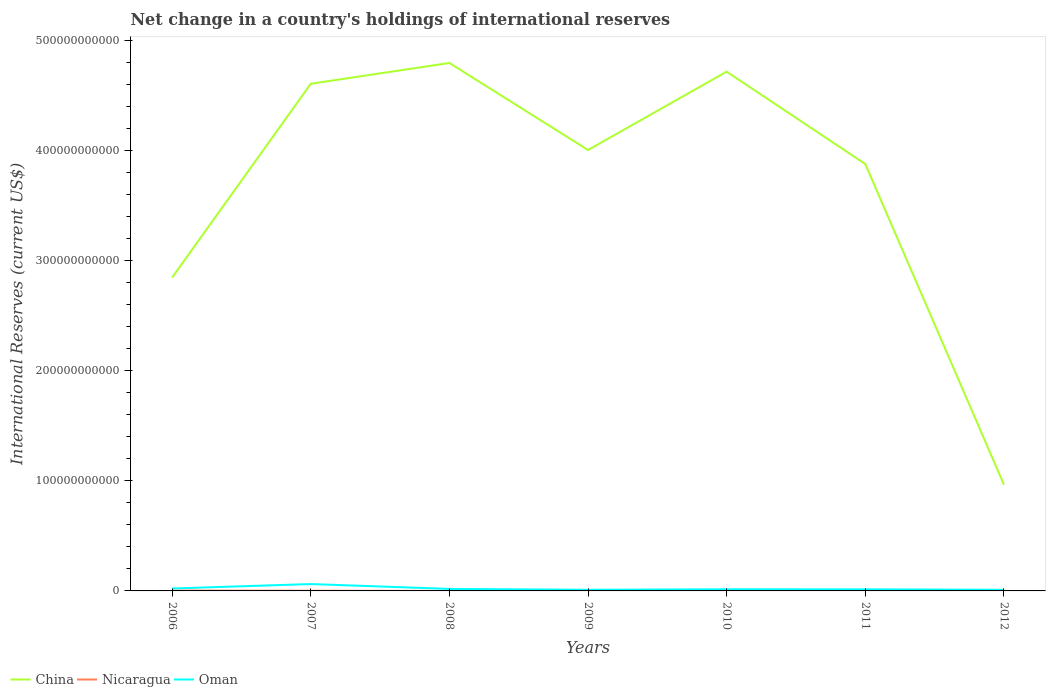Does the line corresponding to China intersect with the line corresponding to Oman?
Your answer should be very brief. No. Is the number of lines equal to the number of legend labels?
Provide a short and direct response. No. Across all years, what is the maximum international reserves in China?
Give a very brief answer. 9.66e+1. What is the total international reserves in Oman in the graph?
Provide a short and direct response. -4.11e+08. What is the difference between the highest and the second highest international reserves in Oman?
Provide a succinct answer. 5.22e+09. What is the difference between the highest and the lowest international reserves in Oman?
Your response must be concise. 2. What is the difference between two consecutive major ticks on the Y-axis?
Your answer should be compact. 1.00e+11. Are the values on the major ticks of Y-axis written in scientific E-notation?
Offer a terse response. No. Does the graph contain any zero values?
Provide a succinct answer. Yes. Does the graph contain grids?
Make the answer very short. No. How many legend labels are there?
Provide a succinct answer. 3. What is the title of the graph?
Provide a short and direct response. Net change in a country's holdings of international reserves. Does "Jordan" appear as one of the legend labels in the graph?
Give a very brief answer. No. What is the label or title of the Y-axis?
Provide a succinct answer. International Reserves (current US$). What is the International Reserves (current US$) in China in 2006?
Give a very brief answer. 2.85e+11. What is the International Reserves (current US$) in Nicaragua in 2006?
Offer a terse response. 3.20e+08. What is the International Reserves (current US$) in Oman in 2006?
Provide a short and direct response. 2.21e+09. What is the International Reserves (current US$) of China in 2007?
Provide a succinct answer. 4.61e+11. What is the International Reserves (current US$) of Nicaragua in 2007?
Your answer should be compact. 1.49e+08. What is the International Reserves (current US$) of Oman in 2007?
Keep it short and to the point. 6.25e+09. What is the International Reserves (current US$) of China in 2008?
Your response must be concise. 4.80e+11. What is the International Reserves (current US$) in Nicaragua in 2008?
Offer a very short reply. 2.91e+06. What is the International Reserves (current US$) of Oman in 2008?
Offer a terse response. 1.83e+09. What is the International Reserves (current US$) of China in 2009?
Ensure brevity in your answer.  4.01e+11. What is the International Reserves (current US$) in Nicaragua in 2009?
Ensure brevity in your answer.  3.85e+08. What is the International Reserves (current US$) in Oman in 2009?
Provide a short and direct response. 1.05e+09. What is the International Reserves (current US$) in China in 2010?
Provide a short and direct response. 4.72e+11. What is the International Reserves (current US$) of Nicaragua in 2010?
Make the answer very short. 2.02e+08. What is the International Reserves (current US$) in Oman in 2010?
Make the answer very short. 1.50e+09. What is the International Reserves (current US$) in China in 2011?
Provide a succinct answer. 3.88e+11. What is the International Reserves (current US$) of Nicaragua in 2011?
Provide a short and direct response. 7.26e+07. What is the International Reserves (current US$) in Oman in 2011?
Ensure brevity in your answer.  1.46e+09. What is the International Reserves (current US$) of China in 2012?
Your response must be concise. 9.66e+1. What is the International Reserves (current US$) of Oman in 2012?
Give a very brief answer. 1.03e+09. Across all years, what is the maximum International Reserves (current US$) in China?
Keep it short and to the point. 4.80e+11. Across all years, what is the maximum International Reserves (current US$) of Nicaragua?
Provide a succinct answer. 3.85e+08. Across all years, what is the maximum International Reserves (current US$) in Oman?
Offer a terse response. 6.25e+09. Across all years, what is the minimum International Reserves (current US$) of China?
Offer a very short reply. 9.66e+1. Across all years, what is the minimum International Reserves (current US$) in Nicaragua?
Ensure brevity in your answer.  0. Across all years, what is the minimum International Reserves (current US$) in Oman?
Give a very brief answer. 1.03e+09. What is the total International Reserves (current US$) of China in the graph?
Your answer should be compact. 2.58e+12. What is the total International Reserves (current US$) in Nicaragua in the graph?
Offer a terse response. 1.13e+09. What is the total International Reserves (current US$) in Oman in the graph?
Offer a terse response. 1.53e+1. What is the difference between the International Reserves (current US$) of China in 2006 and that in 2007?
Make the answer very short. -1.76e+11. What is the difference between the International Reserves (current US$) in Nicaragua in 2006 and that in 2007?
Your answer should be compact. 1.72e+08. What is the difference between the International Reserves (current US$) of Oman in 2006 and that in 2007?
Keep it short and to the point. -4.04e+09. What is the difference between the International Reserves (current US$) of China in 2006 and that in 2008?
Keep it short and to the point. -1.95e+11. What is the difference between the International Reserves (current US$) of Nicaragua in 2006 and that in 2008?
Ensure brevity in your answer.  3.17e+08. What is the difference between the International Reserves (current US$) in Oman in 2006 and that in 2008?
Make the answer very short. 3.79e+08. What is the difference between the International Reserves (current US$) in China in 2006 and that in 2009?
Provide a short and direct response. -1.16e+11. What is the difference between the International Reserves (current US$) of Nicaragua in 2006 and that in 2009?
Your answer should be compact. -6.45e+07. What is the difference between the International Reserves (current US$) of Oman in 2006 and that in 2009?
Provide a succinct answer. 1.16e+09. What is the difference between the International Reserves (current US$) of China in 2006 and that in 2010?
Keep it short and to the point. -1.87e+11. What is the difference between the International Reserves (current US$) of Nicaragua in 2006 and that in 2010?
Provide a short and direct response. 1.18e+08. What is the difference between the International Reserves (current US$) in Oman in 2006 and that in 2010?
Keep it short and to the point. 7.02e+08. What is the difference between the International Reserves (current US$) of China in 2006 and that in 2011?
Offer a very short reply. -1.03e+11. What is the difference between the International Reserves (current US$) of Nicaragua in 2006 and that in 2011?
Your answer should be very brief. 2.48e+08. What is the difference between the International Reserves (current US$) of Oman in 2006 and that in 2011?
Your answer should be compact. 7.45e+08. What is the difference between the International Reserves (current US$) in China in 2006 and that in 2012?
Make the answer very short. 1.88e+11. What is the difference between the International Reserves (current US$) of Oman in 2006 and that in 2012?
Ensure brevity in your answer.  1.17e+09. What is the difference between the International Reserves (current US$) in China in 2007 and that in 2008?
Your response must be concise. -1.89e+1. What is the difference between the International Reserves (current US$) of Nicaragua in 2007 and that in 2008?
Your answer should be compact. 1.46e+08. What is the difference between the International Reserves (current US$) in Oman in 2007 and that in 2008?
Ensure brevity in your answer.  4.42e+09. What is the difference between the International Reserves (current US$) in China in 2007 and that in 2009?
Your answer should be very brief. 6.01e+1. What is the difference between the International Reserves (current US$) in Nicaragua in 2007 and that in 2009?
Ensure brevity in your answer.  -2.36e+08. What is the difference between the International Reserves (current US$) in Oman in 2007 and that in 2009?
Offer a terse response. 5.20e+09. What is the difference between the International Reserves (current US$) in China in 2007 and that in 2010?
Your answer should be very brief. -1.10e+1. What is the difference between the International Reserves (current US$) of Nicaragua in 2007 and that in 2010?
Your answer should be compact. -5.34e+07. What is the difference between the International Reserves (current US$) in Oman in 2007 and that in 2010?
Keep it short and to the point. 4.75e+09. What is the difference between the International Reserves (current US$) in China in 2007 and that in 2011?
Give a very brief answer. 7.29e+1. What is the difference between the International Reserves (current US$) in Nicaragua in 2007 and that in 2011?
Your answer should be compact. 7.60e+07. What is the difference between the International Reserves (current US$) in Oman in 2007 and that in 2011?
Give a very brief answer. 4.79e+09. What is the difference between the International Reserves (current US$) of China in 2007 and that in 2012?
Make the answer very short. 3.64e+11. What is the difference between the International Reserves (current US$) in Oman in 2007 and that in 2012?
Offer a very short reply. 5.22e+09. What is the difference between the International Reserves (current US$) in China in 2008 and that in 2009?
Give a very brief answer. 7.90e+1. What is the difference between the International Reserves (current US$) of Nicaragua in 2008 and that in 2009?
Offer a terse response. -3.82e+08. What is the difference between the International Reserves (current US$) in Oman in 2008 and that in 2009?
Offer a terse response. 7.77e+08. What is the difference between the International Reserves (current US$) in China in 2008 and that in 2010?
Provide a succinct answer. 7.89e+09. What is the difference between the International Reserves (current US$) in Nicaragua in 2008 and that in 2010?
Provide a succinct answer. -1.99e+08. What is the difference between the International Reserves (current US$) in Oman in 2008 and that in 2010?
Offer a very short reply. 3.23e+08. What is the difference between the International Reserves (current US$) of China in 2008 and that in 2011?
Provide a succinct answer. 9.18e+1. What is the difference between the International Reserves (current US$) in Nicaragua in 2008 and that in 2011?
Your answer should be compact. -6.97e+07. What is the difference between the International Reserves (current US$) of Oman in 2008 and that in 2011?
Give a very brief answer. 3.66e+08. What is the difference between the International Reserves (current US$) of China in 2008 and that in 2012?
Your answer should be compact. 3.83e+11. What is the difference between the International Reserves (current US$) in Oman in 2008 and that in 2012?
Offer a very short reply. 7.94e+08. What is the difference between the International Reserves (current US$) in China in 2009 and that in 2010?
Make the answer very short. -7.12e+1. What is the difference between the International Reserves (current US$) of Nicaragua in 2009 and that in 2010?
Offer a terse response. 1.83e+08. What is the difference between the International Reserves (current US$) of Oman in 2009 and that in 2010?
Offer a terse response. -4.54e+08. What is the difference between the International Reserves (current US$) of China in 2009 and that in 2011?
Your answer should be very brief. 1.27e+1. What is the difference between the International Reserves (current US$) of Nicaragua in 2009 and that in 2011?
Make the answer very short. 3.12e+08. What is the difference between the International Reserves (current US$) of Oman in 2009 and that in 2011?
Your answer should be compact. -4.11e+08. What is the difference between the International Reserves (current US$) of China in 2009 and that in 2012?
Make the answer very short. 3.04e+11. What is the difference between the International Reserves (current US$) of Oman in 2009 and that in 2012?
Give a very brief answer. 1.64e+07. What is the difference between the International Reserves (current US$) in China in 2010 and that in 2011?
Offer a very short reply. 8.39e+1. What is the difference between the International Reserves (current US$) of Nicaragua in 2010 and that in 2011?
Provide a succinct answer. 1.29e+08. What is the difference between the International Reserves (current US$) in Oman in 2010 and that in 2011?
Ensure brevity in your answer.  4.31e+07. What is the difference between the International Reserves (current US$) of China in 2010 and that in 2012?
Your answer should be compact. 3.75e+11. What is the difference between the International Reserves (current US$) of Oman in 2010 and that in 2012?
Your answer should be compact. 4.71e+08. What is the difference between the International Reserves (current US$) in China in 2011 and that in 2012?
Ensure brevity in your answer.  2.91e+11. What is the difference between the International Reserves (current US$) in Oman in 2011 and that in 2012?
Ensure brevity in your answer.  4.28e+08. What is the difference between the International Reserves (current US$) in China in 2006 and the International Reserves (current US$) in Nicaragua in 2007?
Your answer should be very brief. 2.85e+11. What is the difference between the International Reserves (current US$) of China in 2006 and the International Reserves (current US$) of Oman in 2007?
Your answer should be very brief. 2.78e+11. What is the difference between the International Reserves (current US$) in Nicaragua in 2006 and the International Reserves (current US$) in Oman in 2007?
Make the answer very short. -5.93e+09. What is the difference between the International Reserves (current US$) in China in 2006 and the International Reserves (current US$) in Nicaragua in 2008?
Your answer should be compact. 2.85e+11. What is the difference between the International Reserves (current US$) in China in 2006 and the International Reserves (current US$) in Oman in 2008?
Provide a succinct answer. 2.83e+11. What is the difference between the International Reserves (current US$) of Nicaragua in 2006 and the International Reserves (current US$) of Oman in 2008?
Keep it short and to the point. -1.51e+09. What is the difference between the International Reserves (current US$) of China in 2006 and the International Reserves (current US$) of Nicaragua in 2009?
Your answer should be compact. 2.84e+11. What is the difference between the International Reserves (current US$) of China in 2006 and the International Reserves (current US$) of Oman in 2009?
Your response must be concise. 2.84e+11. What is the difference between the International Reserves (current US$) of Nicaragua in 2006 and the International Reserves (current US$) of Oman in 2009?
Make the answer very short. -7.30e+08. What is the difference between the International Reserves (current US$) of China in 2006 and the International Reserves (current US$) of Nicaragua in 2010?
Keep it short and to the point. 2.84e+11. What is the difference between the International Reserves (current US$) of China in 2006 and the International Reserves (current US$) of Oman in 2010?
Provide a short and direct response. 2.83e+11. What is the difference between the International Reserves (current US$) in Nicaragua in 2006 and the International Reserves (current US$) in Oman in 2010?
Your response must be concise. -1.18e+09. What is the difference between the International Reserves (current US$) of China in 2006 and the International Reserves (current US$) of Nicaragua in 2011?
Give a very brief answer. 2.85e+11. What is the difference between the International Reserves (current US$) of China in 2006 and the International Reserves (current US$) of Oman in 2011?
Give a very brief answer. 2.83e+11. What is the difference between the International Reserves (current US$) of Nicaragua in 2006 and the International Reserves (current US$) of Oman in 2011?
Make the answer very short. -1.14e+09. What is the difference between the International Reserves (current US$) in China in 2006 and the International Reserves (current US$) in Oman in 2012?
Ensure brevity in your answer.  2.84e+11. What is the difference between the International Reserves (current US$) of Nicaragua in 2006 and the International Reserves (current US$) of Oman in 2012?
Your answer should be compact. -7.13e+08. What is the difference between the International Reserves (current US$) of China in 2007 and the International Reserves (current US$) of Nicaragua in 2008?
Keep it short and to the point. 4.61e+11. What is the difference between the International Reserves (current US$) of China in 2007 and the International Reserves (current US$) of Oman in 2008?
Your answer should be very brief. 4.59e+11. What is the difference between the International Reserves (current US$) in Nicaragua in 2007 and the International Reserves (current US$) in Oman in 2008?
Your answer should be compact. -1.68e+09. What is the difference between the International Reserves (current US$) of China in 2007 and the International Reserves (current US$) of Nicaragua in 2009?
Your answer should be very brief. 4.60e+11. What is the difference between the International Reserves (current US$) of China in 2007 and the International Reserves (current US$) of Oman in 2009?
Make the answer very short. 4.60e+11. What is the difference between the International Reserves (current US$) of Nicaragua in 2007 and the International Reserves (current US$) of Oman in 2009?
Your answer should be very brief. -9.01e+08. What is the difference between the International Reserves (current US$) in China in 2007 and the International Reserves (current US$) in Nicaragua in 2010?
Keep it short and to the point. 4.60e+11. What is the difference between the International Reserves (current US$) in China in 2007 and the International Reserves (current US$) in Oman in 2010?
Provide a succinct answer. 4.59e+11. What is the difference between the International Reserves (current US$) of Nicaragua in 2007 and the International Reserves (current US$) of Oman in 2010?
Your answer should be compact. -1.36e+09. What is the difference between the International Reserves (current US$) in China in 2007 and the International Reserves (current US$) in Nicaragua in 2011?
Ensure brevity in your answer.  4.61e+11. What is the difference between the International Reserves (current US$) in China in 2007 and the International Reserves (current US$) in Oman in 2011?
Provide a succinct answer. 4.59e+11. What is the difference between the International Reserves (current US$) in Nicaragua in 2007 and the International Reserves (current US$) in Oman in 2011?
Offer a very short reply. -1.31e+09. What is the difference between the International Reserves (current US$) of China in 2007 and the International Reserves (current US$) of Oman in 2012?
Your answer should be very brief. 4.60e+11. What is the difference between the International Reserves (current US$) of Nicaragua in 2007 and the International Reserves (current US$) of Oman in 2012?
Ensure brevity in your answer.  -8.85e+08. What is the difference between the International Reserves (current US$) of China in 2008 and the International Reserves (current US$) of Nicaragua in 2009?
Give a very brief answer. 4.79e+11. What is the difference between the International Reserves (current US$) in China in 2008 and the International Reserves (current US$) in Oman in 2009?
Keep it short and to the point. 4.79e+11. What is the difference between the International Reserves (current US$) of Nicaragua in 2008 and the International Reserves (current US$) of Oman in 2009?
Give a very brief answer. -1.05e+09. What is the difference between the International Reserves (current US$) of China in 2008 and the International Reserves (current US$) of Nicaragua in 2010?
Keep it short and to the point. 4.79e+11. What is the difference between the International Reserves (current US$) of China in 2008 and the International Reserves (current US$) of Oman in 2010?
Make the answer very short. 4.78e+11. What is the difference between the International Reserves (current US$) of Nicaragua in 2008 and the International Reserves (current US$) of Oman in 2010?
Make the answer very short. -1.50e+09. What is the difference between the International Reserves (current US$) of China in 2008 and the International Reserves (current US$) of Nicaragua in 2011?
Ensure brevity in your answer.  4.79e+11. What is the difference between the International Reserves (current US$) in China in 2008 and the International Reserves (current US$) in Oman in 2011?
Provide a short and direct response. 4.78e+11. What is the difference between the International Reserves (current US$) of Nicaragua in 2008 and the International Reserves (current US$) of Oman in 2011?
Your answer should be very brief. -1.46e+09. What is the difference between the International Reserves (current US$) of China in 2008 and the International Reserves (current US$) of Oman in 2012?
Your response must be concise. 4.79e+11. What is the difference between the International Reserves (current US$) of Nicaragua in 2008 and the International Reserves (current US$) of Oman in 2012?
Make the answer very short. -1.03e+09. What is the difference between the International Reserves (current US$) in China in 2009 and the International Reserves (current US$) in Nicaragua in 2010?
Ensure brevity in your answer.  4.00e+11. What is the difference between the International Reserves (current US$) of China in 2009 and the International Reserves (current US$) of Oman in 2010?
Keep it short and to the point. 3.99e+11. What is the difference between the International Reserves (current US$) in Nicaragua in 2009 and the International Reserves (current US$) in Oman in 2010?
Make the answer very short. -1.12e+09. What is the difference between the International Reserves (current US$) of China in 2009 and the International Reserves (current US$) of Nicaragua in 2011?
Make the answer very short. 4.00e+11. What is the difference between the International Reserves (current US$) in China in 2009 and the International Reserves (current US$) in Oman in 2011?
Provide a succinct answer. 3.99e+11. What is the difference between the International Reserves (current US$) in Nicaragua in 2009 and the International Reserves (current US$) in Oman in 2011?
Provide a short and direct response. -1.08e+09. What is the difference between the International Reserves (current US$) of China in 2009 and the International Reserves (current US$) of Oman in 2012?
Offer a very short reply. 3.99e+11. What is the difference between the International Reserves (current US$) of Nicaragua in 2009 and the International Reserves (current US$) of Oman in 2012?
Offer a very short reply. -6.49e+08. What is the difference between the International Reserves (current US$) in China in 2010 and the International Reserves (current US$) in Nicaragua in 2011?
Offer a very short reply. 4.72e+11. What is the difference between the International Reserves (current US$) in China in 2010 and the International Reserves (current US$) in Oman in 2011?
Offer a terse response. 4.70e+11. What is the difference between the International Reserves (current US$) in Nicaragua in 2010 and the International Reserves (current US$) in Oman in 2011?
Ensure brevity in your answer.  -1.26e+09. What is the difference between the International Reserves (current US$) of China in 2010 and the International Reserves (current US$) of Oman in 2012?
Offer a very short reply. 4.71e+11. What is the difference between the International Reserves (current US$) in Nicaragua in 2010 and the International Reserves (current US$) in Oman in 2012?
Give a very brief answer. -8.31e+08. What is the difference between the International Reserves (current US$) in China in 2011 and the International Reserves (current US$) in Oman in 2012?
Ensure brevity in your answer.  3.87e+11. What is the difference between the International Reserves (current US$) of Nicaragua in 2011 and the International Reserves (current US$) of Oman in 2012?
Your response must be concise. -9.61e+08. What is the average International Reserves (current US$) of China per year?
Make the answer very short. 3.69e+11. What is the average International Reserves (current US$) in Nicaragua per year?
Give a very brief answer. 1.62e+08. What is the average International Reserves (current US$) in Oman per year?
Your response must be concise. 2.19e+09. In the year 2006, what is the difference between the International Reserves (current US$) in China and International Reserves (current US$) in Nicaragua?
Provide a succinct answer. 2.84e+11. In the year 2006, what is the difference between the International Reserves (current US$) of China and International Reserves (current US$) of Oman?
Offer a very short reply. 2.82e+11. In the year 2006, what is the difference between the International Reserves (current US$) in Nicaragua and International Reserves (current US$) in Oman?
Provide a succinct answer. -1.89e+09. In the year 2007, what is the difference between the International Reserves (current US$) in China and International Reserves (current US$) in Nicaragua?
Your answer should be very brief. 4.61e+11. In the year 2007, what is the difference between the International Reserves (current US$) in China and International Reserves (current US$) in Oman?
Offer a terse response. 4.54e+11. In the year 2007, what is the difference between the International Reserves (current US$) of Nicaragua and International Reserves (current US$) of Oman?
Your response must be concise. -6.10e+09. In the year 2008, what is the difference between the International Reserves (current US$) of China and International Reserves (current US$) of Nicaragua?
Keep it short and to the point. 4.80e+11. In the year 2008, what is the difference between the International Reserves (current US$) of China and International Reserves (current US$) of Oman?
Your answer should be compact. 4.78e+11. In the year 2008, what is the difference between the International Reserves (current US$) in Nicaragua and International Reserves (current US$) in Oman?
Offer a terse response. -1.82e+09. In the year 2009, what is the difference between the International Reserves (current US$) of China and International Reserves (current US$) of Nicaragua?
Your answer should be very brief. 4.00e+11. In the year 2009, what is the difference between the International Reserves (current US$) in China and International Reserves (current US$) in Oman?
Make the answer very short. 3.99e+11. In the year 2009, what is the difference between the International Reserves (current US$) of Nicaragua and International Reserves (current US$) of Oman?
Your response must be concise. -6.65e+08. In the year 2010, what is the difference between the International Reserves (current US$) in China and International Reserves (current US$) in Nicaragua?
Provide a succinct answer. 4.71e+11. In the year 2010, what is the difference between the International Reserves (current US$) in China and International Reserves (current US$) in Oman?
Provide a short and direct response. 4.70e+11. In the year 2010, what is the difference between the International Reserves (current US$) in Nicaragua and International Reserves (current US$) in Oman?
Offer a very short reply. -1.30e+09. In the year 2011, what is the difference between the International Reserves (current US$) of China and International Reserves (current US$) of Nicaragua?
Give a very brief answer. 3.88e+11. In the year 2011, what is the difference between the International Reserves (current US$) of China and International Reserves (current US$) of Oman?
Make the answer very short. 3.86e+11. In the year 2011, what is the difference between the International Reserves (current US$) of Nicaragua and International Reserves (current US$) of Oman?
Your response must be concise. -1.39e+09. In the year 2012, what is the difference between the International Reserves (current US$) of China and International Reserves (current US$) of Oman?
Make the answer very short. 9.55e+1. What is the ratio of the International Reserves (current US$) in China in 2006 to that in 2007?
Give a very brief answer. 0.62. What is the ratio of the International Reserves (current US$) in Nicaragua in 2006 to that in 2007?
Your response must be concise. 2.16. What is the ratio of the International Reserves (current US$) in Oman in 2006 to that in 2007?
Your response must be concise. 0.35. What is the ratio of the International Reserves (current US$) in China in 2006 to that in 2008?
Provide a short and direct response. 0.59. What is the ratio of the International Reserves (current US$) in Nicaragua in 2006 to that in 2008?
Your response must be concise. 110.14. What is the ratio of the International Reserves (current US$) of Oman in 2006 to that in 2008?
Keep it short and to the point. 1.21. What is the ratio of the International Reserves (current US$) of China in 2006 to that in 2009?
Your answer should be very brief. 0.71. What is the ratio of the International Reserves (current US$) in Nicaragua in 2006 to that in 2009?
Provide a succinct answer. 0.83. What is the ratio of the International Reserves (current US$) in Oman in 2006 to that in 2009?
Make the answer very short. 2.1. What is the ratio of the International Reserves (current US$) of China in 2006 to that in 2010?
Make the answer very short. 0.6. What is the ratio of the International Reserves (current US$) of Nicaragua in 2006 to that in 2010?
Offer a very short reply. 1.59. What is the ratio of the International Reserves (current US$) of Oman in 2006 to that in 2010?
Give a very brief answer. 1.47. What is the ratio of the International Reserves (current US$) of China in 2006 to that in 2011?
Give a very brief answer. 0.73. What is the ratio of the International Reserves (current US$) in Nicaragua in 2006 to that in 2011?
Provide a succinct answer. 4.41. What is the ratio of the International Reserves (current US$) in Oman in 2006 to that in 2011?
Offer a terse response. 1.51. What is the ratio of the International Reserves (current US$) in China in 2006 to that in 2012?
Your response must be concise. 2.95. What is the ratio of the International Reserves (current US$) of Oman in 2006 to that in 2012?
Your answer should be compact. 2.13. What is the ratio of the International Reserves (current US$) in China in 2007 to that in 2008?
Provide a short and direct response. 0.96. What is the ratio of the International Reserves (current US$) of Nicaragua in 2007 to that in 2008?
Keep it short and to the point. 51.1. What is the ratio of the International Reserves (current US$) in Oman in 2007 to that in 2008?
Your response must be concise. 3.42. What is the ratio of the International Reserves (current US$) in China in 2007 to that in 2009?
Provide a succinct answer. 1.15. What is the ratio of the International Reserves (current US$) in Nicaragua in 2007 to that in 2009?
Ensure brevity in your answer.  0.39. What is the ratio of the International Reserves (current US$) in Oman in 2007 to that in 2009?
Offer a very short reply. 5.95. What is the ratio of the International Reserves (current US$) of China in 2007 to that in 2010?
Your answer should be very brief. 0.98. What is the ratio of the International Reserves (current US$) in Nicaragua in 2007 to that in 2010?
Provide a succinct answer. 0.74. What is the ratio of the International Reserves (current US$) in Oman in 2007 to that in 2010?
Offer a terse response. 4.16. What is the ratio of the International Reserves (current US$) of China in 2007 to that in 2011?
Offer a very short reply. 1.19. What is the ratio of the International Reserves (current US$) in Nicaragua in 2007 to that in 2011?
Provide a succinct answer. 2.05. What is the ratio of the International Reserves (current US$) of Oman in 2007 to that in 2011?
Offer a terse response. 4.28. What is the ratio of the International Reserves (current US$) in China in 2007 to that in 2012?
Ensure brevity in your answer.  4.77. What is the ratio of the International Reserves (current US$) in Oman in 2007 to that in 2012?
Your response must be concise. 6.05. What is the ratio of the International Reserves (current US$) in China in 2008 to that in 2009?
Provide a succinct answer. 1.2. What is the ratio of the International Reserves (current US$) in Nicaragua in 2008 to that in 2009?
Offer a very short reply. 0.01. What is the ratio of the International Reserves (current US$) in Oman in 2008 to that in 2009?
Your response must be concise. 1.74. What is the ratio of the International Reserves (current US$) of China in 2008 to that in 2010?
Provide a succinct answer. 1.02. What is the ratio of the International Reserves (current US$) in Nicaragua in 2008 to that in 2010?
Ensure brevity in your answer.  0.01. What is the ratio of the International Reserves (current US$) of Oman in 2008 to that in 2010?
Keep it short and to the point. 1.21. What is the ratio of the International Reserves (current US$) in China in 2008 to that in 2011?
Offer a terse response. 1.24. What is the ratio of the International Reserves (current US$) in Nicaragua in 2008 to that in 2011?
Ensure brevity in your answer.  0.04. What is the ratio of the International Reserves (current US$) of Oman in 2008 to that in 2011?
Your answer should be very brief. 1.25. What is the ratio of the International Reserves (current US$) in China in 2008 to that in 2012?
Your answer should be compact. 4.97. What is the ratio of the International Reserves (current US$) in Oman in 2008 to that in 2012?
Provide a short and direct response. 1.77. What is the ratio of the International Reserves (current US$) in China in 2009 to that in 2010?
Make the answer very short. 0.85. What is the ratio of the International Reserves (current US$) of Nicaragua in 2009 to that in 2010?
Your response must be concise. 1.91. What is the ratio of the International Reserves (current US$) of Oman in 2009 to that in 2010?
Your answer should be compact. 0.7. What is the ratio of the International Reserves (current US$) in China in 2009 to that in 2011?
Give a very brief answer. 1.03. What is the ratio of the International Reserves (current US$) of Nicaragua in 2009 to that in 2011?
Ensure brevity in your answer.  5.3. What is the ratio of the International Reserves (current US$) of Oman in 2009 to that in 2011?
Offer a terse response. 0.72. What is the ratio of the International Reserves (current US$) in China in 2009 to that in 2012?
Offer a very short reply. 4.15. What is the ratio of the International Reserves (current US$) of Oman in 2009 to that in 2012?
Your answer should be very brief. 1.02. What is the ratio of the International Reserves (current US$) of China in 2010 to that in 2011?
Give a very brief answer. 1.22. What is the ratio of the International Reserves (current US$) in Nicaragua in 2010 to that in 2011?
Provide a short and direct response. 2.78. What is the ratio of the International Reserves (current US$) of Oman in 2010 to that in 2011?
Ensure brevity in your answer.  1.03. What is the ratio of the International Reserves (current US$) in China in 2010 to that in 2012?
Keep it short and to the point. 4.88. What is the ratio of the International Reserves (current US$) in Oman in 2010 to that in 2012?
Your response must be concise. 1.46. What is the ratio of the International Reserves (current US$) in China in 2011 to that in 2012?
Your answer should be compact. 4.02. What is the ratio of the International Reserves (current US$) in Oman in 2011 to that in 2012?
Provide a succinct answer. 1.41. What is the difference between the highest and the second highest International Reserves (current US$) in China?
Your response must be concise. 7.89e+09. What is the difference between the highest and the second highest International Reserves (current US$) of Nicaragua?
Offer a terse response. 6.45e+07. What is the difference between the highest and the second highest International Reserves (current US$) in Oman?
Provide a succinct answer. 4.04e+09. What is the difference between the highest and the lowest International Reserves (current US$) of China?
Your response must be concise. 3.83e+11. What is the difference between the highest and the lowest International Reserves (current US$) in Nicaragua?
Keep it short and to the point. 3.85e+08. What is the difference between the highest and the lowest International Reserves (current US$) in Oman?
Ensure brevity in your answer.  5.22e+09. 